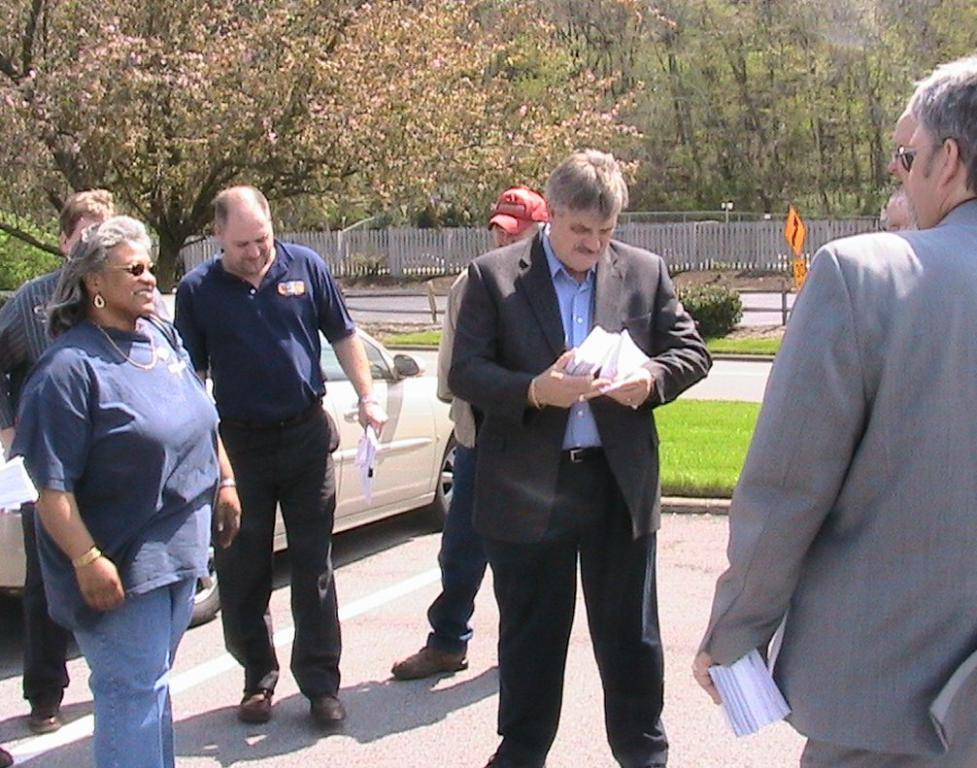What is happening in the image involving the people? The people in the image are standing and holding something. Can you describe the background of the image? In the background, there is a car, trees, sign boards, and fencing. What might the people be holding in the image? The people are holding something, but the specific object cannot be determined from the provided facts. What type of cloud can be seen in the image? There is no cloud visible in the image; only a car, trees, sign boards, and fencing are present in the background. 